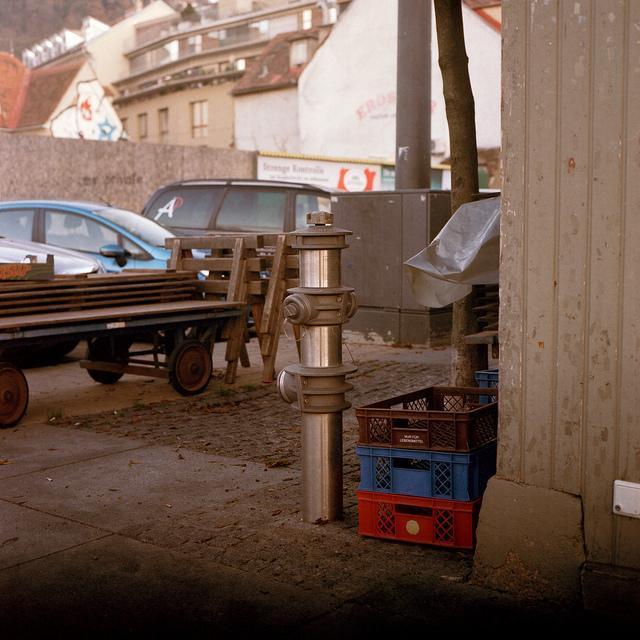How many crates are in  the photo?
Give a very brief answer. 3. How many blue cars are in the photo?
Give a very brief answer. 1. How many wheels are on the cart?
Give a very brief answer. 4. How many cars are visible?
Give a very brief answer. 3. 